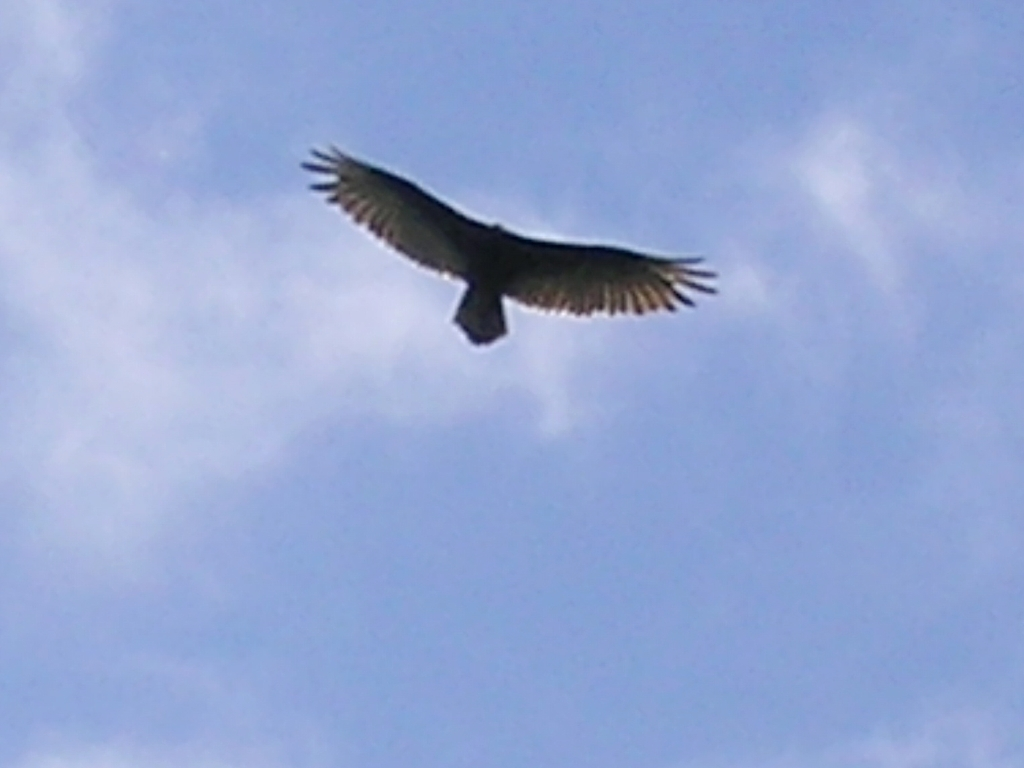Is the image well-lit? The image appears to be backlit, with the primary light source coming from behind the subject, which in this case is a bird in flight. The lighting condition emphasizes the silhouette of the bird against a mostly clear sky but does not offer much detail on the bird itself. 